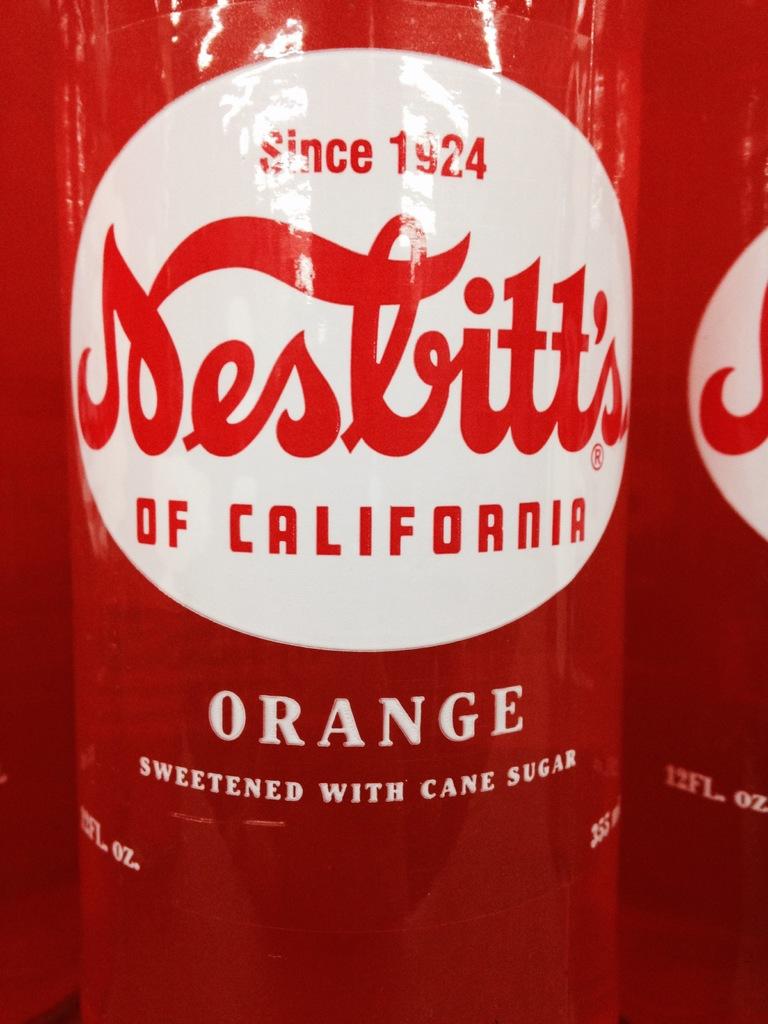What year is on this bottle?
Give a very brief answer. 1924. What kind of sugar is used to sweeten?
Give a very brief answer. Cane sugar. 